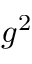Convert formula to latex. <formula><loc_0><loc_0><loc_500><loc_500>g ^ { 2 }</formula> 